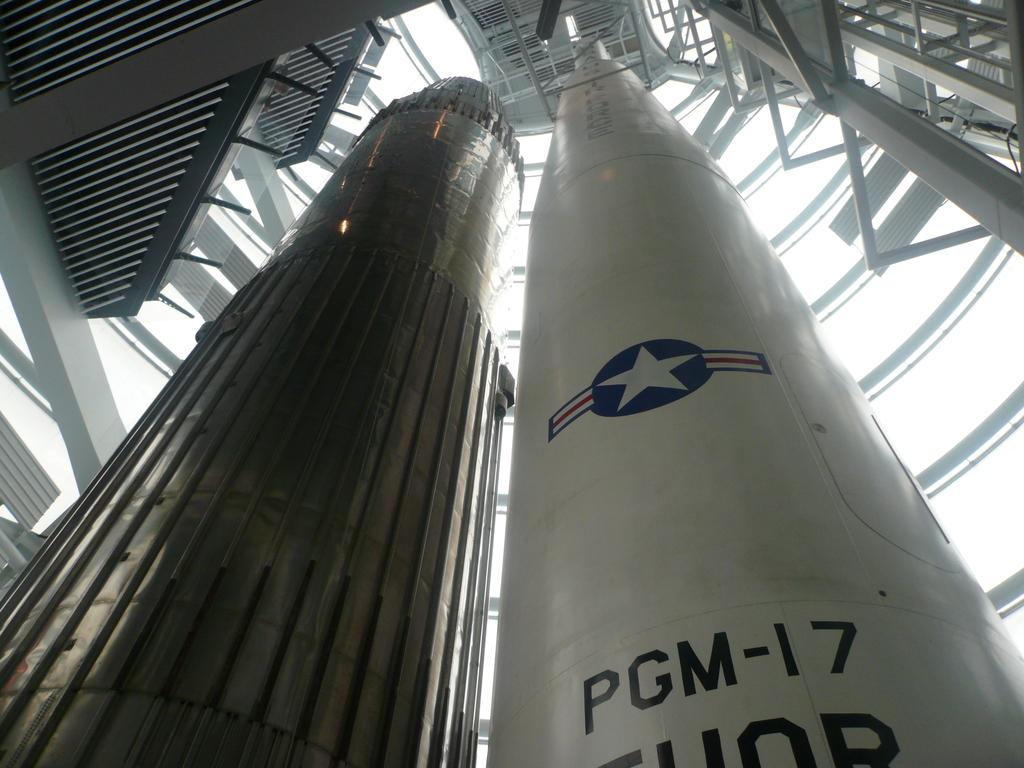What type of objects are the main focus of the image? There are missiles in the image. What can be seen in the background of the image? There are rods in the background of the image. Is there any text present on any of the objects in the image? Yes, there is some text on one of the missiles. What type of juice can be seen being poured in the image? There is no juice present in the image; it features missiles and rods in the background. 